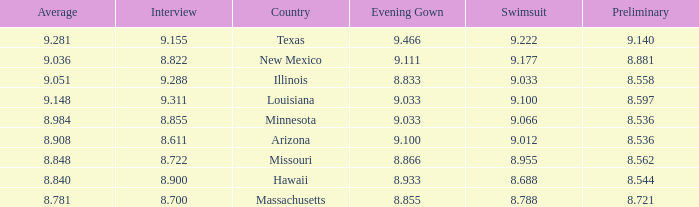What was the average score for the country with the evening gown score of 9.100? 1.0. 